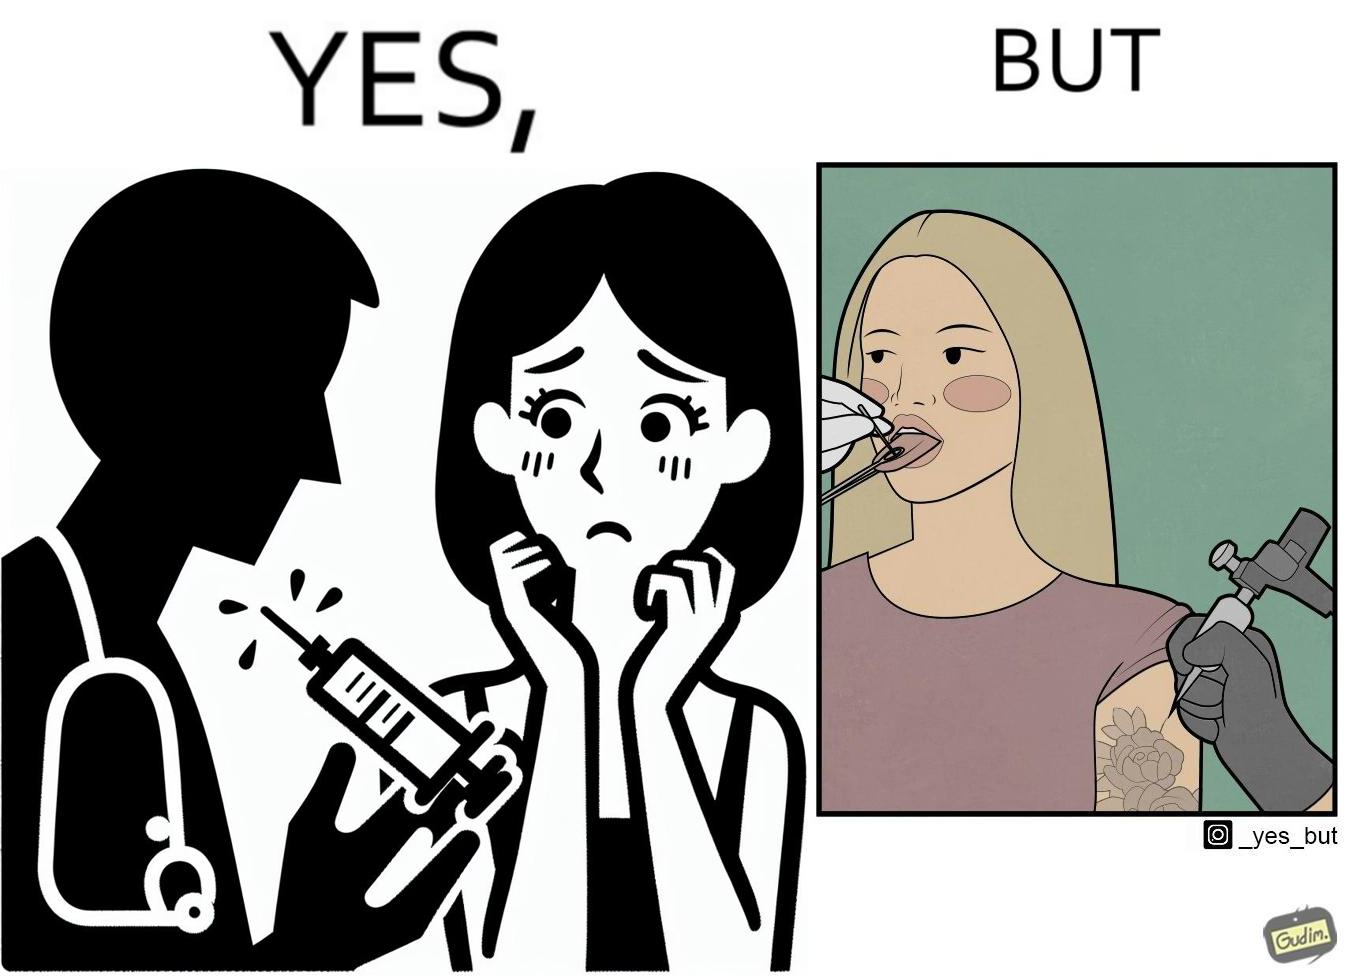Explain why this image is satirical. The image is funny becuase while the woman is scared of getting an injection which is for her benefit, she is not afraid of getting a piercing or a tattoo which are not going to help her in any way. 